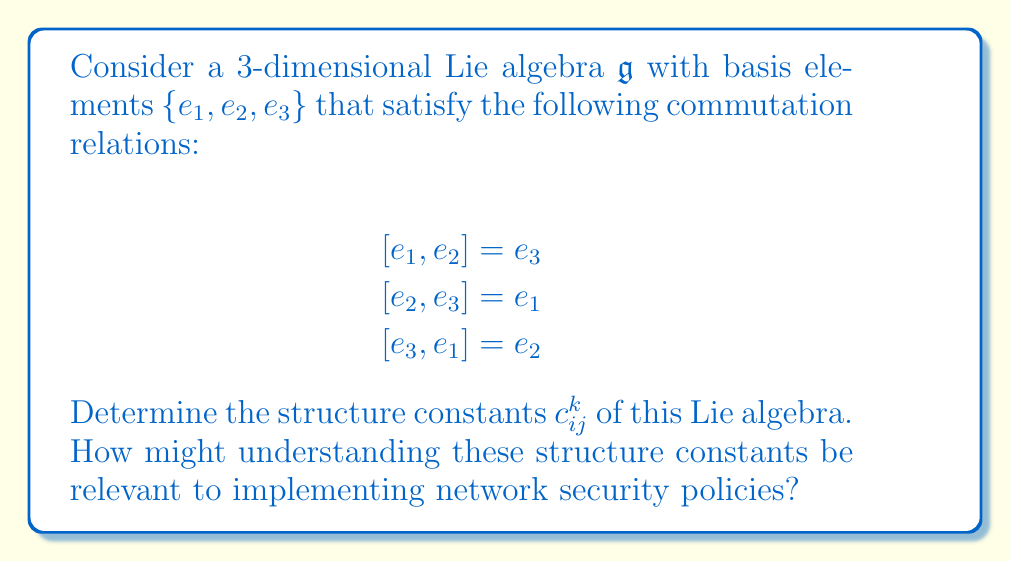Can you answer this question? To determine the structure constants of a Lie algebra, we need to express each commutator in terms of the basis elements:

$$[e_i, e_j] = \sum_{k=1}^3 c_{ij}^k e_k$$

where $c_{ij}^k$ are the structure constants.

Let's analyze each commutation relation:

1) $[e_1, e_2] = e_3$
   This implies $c_{12}^3 = 1$, and $c_{12}^1 = c_{12}^2 = 0$

2) $[e_2, e_3] = e_1$
   This implies $c_{23}^1 = 1$, and $c_{23}^2 = c_{23}^3 = 0$

3) $[e_3, e_1] = e_2$
   This implies $c_{31}^2 = 1$, and $c_{31}^1 = c_{31}^3 = 0$

Note that the structure constants are antisymmetric in the lower indices:
$c_{ij}^k = -c_{ji}^k$

So, we also have:
$c_{21}^3 = -1$, $c_{32}^1 = -1$, $c_{13}^2 = -1$

All other structure constants are zero.

Understanding these structure constants can be relevant to network security in the following way:

1) The structure constants define how different elements of the algebra interact, which can be analogous to how different components of a network interact.

2) The cyclic nature of these commutation relations ($e_1 \rightarrow e_2 \rightarrow e_3 \rightarrow e_1$) could represent a cyclic dependency in network protocols or security measures.

3) The non-zero structure constants indicate which interactions are significant, potentially highlighting critical points in a network where security measures should be focused.

4) The antisymmetry of the structure constants ($c_{ij}^k = -c_{ji}^k$) might represent bidirectional relationships in network communications, where actions in one direction have opposite effects in the other direction.
Answer: The non-zero structure constants are:

$$c_{12}^3 = 1, \quad c_{23}^1 = 1, \quad c_{31}^2 = 1$$
$$c_{21}^3 = -1, \quad c_{32}^1 = -1, \quad c_{13}^2 = -1$$

All other $c_{ij}^k = 0$. 